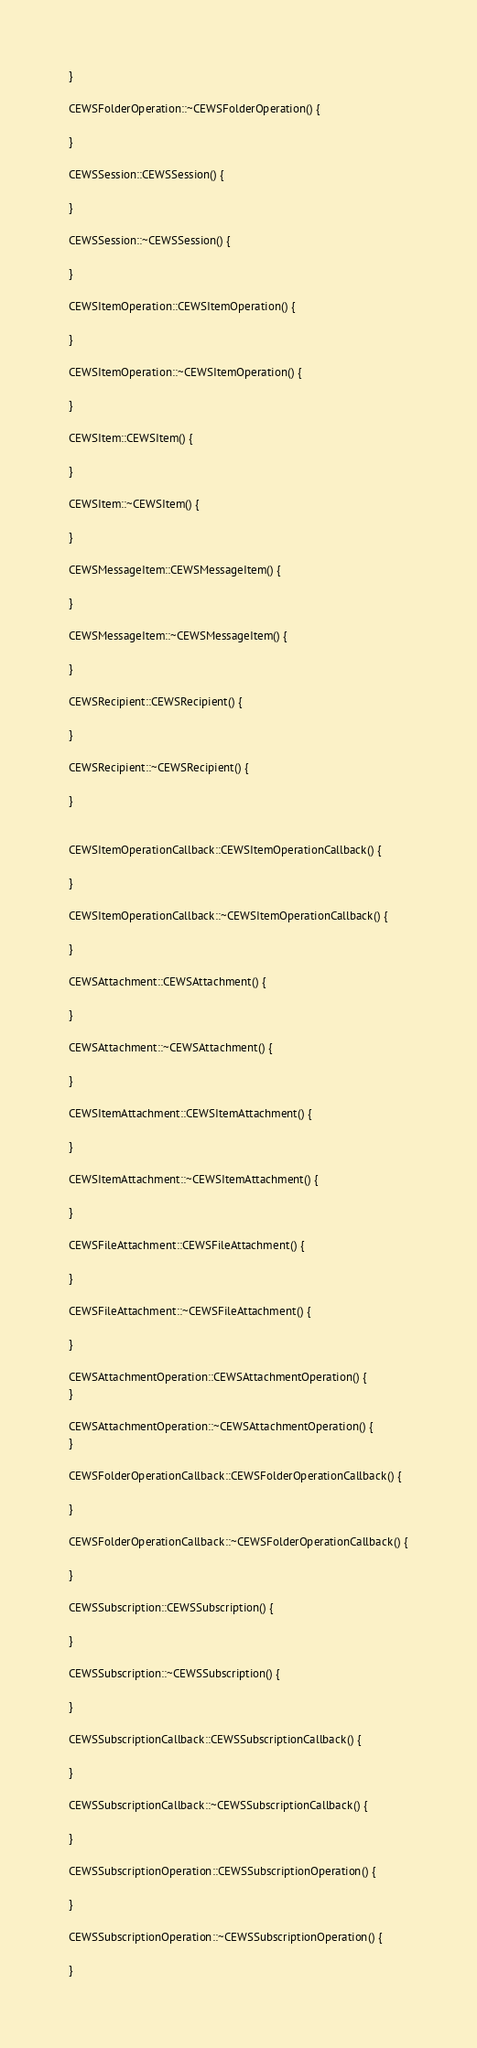Convert code to text. <code><loc_0><loc_0><loc_500><loc_500><_C++_>
}

CEWSFolderOperation::~CEWSFolderOperation() {

}

CEWSSession::CEWSSession() {

}

CEWSSession::~CEWSSession() {

}

CEWSItemOperation::CEWSItemOperation() {

}

CEWSItemOperation::~CEWSItemOperation() {

}

CEWSItem::CEWSItem() {

}

CEWSItem::~CEWSItem() {

}

CEWSMessageItem::CEWSMessageItem() {

}

CEWSMessageItem::~CEWSMessageItem() {

}

CEWSRecipient::CEWSRecipient() {

}

CEWSRecipient::~CEWSRecipient() {

}


CEWSItemOperationCallback::CEWSItemOperationCallback() {

}

CEWSItemOperationCallback::~CEWSItemOperationCallback() {

}

CEWSAttachment::CEWSAttachment() {

}

CEWSAttachment::~CEWSAttachment() {

}

CEWSItemAttachment::CEWSItemAttachment() {

}

CEWSItemAttachment::~CEWSItemAttachment() {

}

CEWSFileAttachment::CEWSFileAttachment() {

}

CEWSFileAttachment::~CEWSFileAttachment() {

}

CEWSAttachmentOperation::CEWSAttachmentOperation() {
}

CEWSAttachmentOperation::~CEWSAttachmentOperation() {
}

CEWSFolderOperationCallback::CEWSFolderOperationCallback() {

}

CEWSFolderOperationCallback::~CEWSFolderOperationCallback() {

}

CEWSSubscription::CEWSSubscription() {

}

CEWSSubscription::~CEWSSubscription() {

}

CEWSSubscriptionCallback::CEWSSubscriptionCallback() {

}

CEWSSubscriptionCallback::~CEWSSubscriptionCallback() {

}

CEWSSubscriptionOperation::CEWSSubscriptionOperation() {

}

CEWSSubscriptionOperation::~CEWSSubscriptionOperation() {

}
</code> 